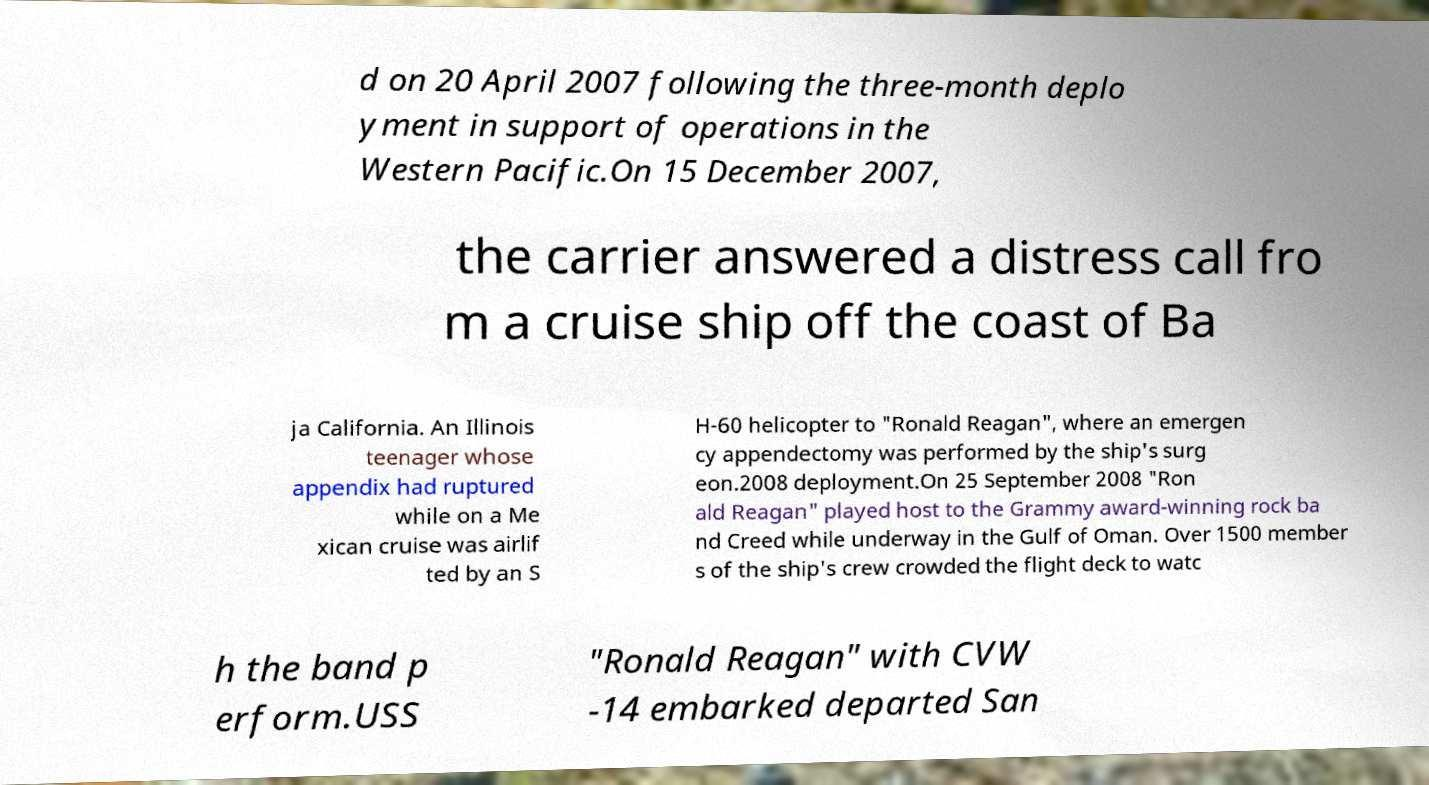There's text embedded in this image that I need extracted. Can you transcribe it verbatim? d on 20 April 2007 following the three-month deplo yment in support of operations in the Western Pacific.On 15 December 2007, the carrier answered a distress call fro m a cruise ship off the coast of Ba ja California. An Illinois teenager whose appendix had ruptured while on a Me xican cruise was airlif ted by an S H-60 helicopter to "Ronald Reagan", where an emergen cy appendectomy was performed by the ship's surg eon.2008 deployment.On 25 September 2008 "Ron ald Reagan" played host to the Grammy award-winning rock ba nd Creed while underway in the Gulf of Oman. Over 1500 member s of the ship's crew crowded the flight deck to watc h the band p erform.USS "Ronald Reagan" with CVW -14 embarked departed San 